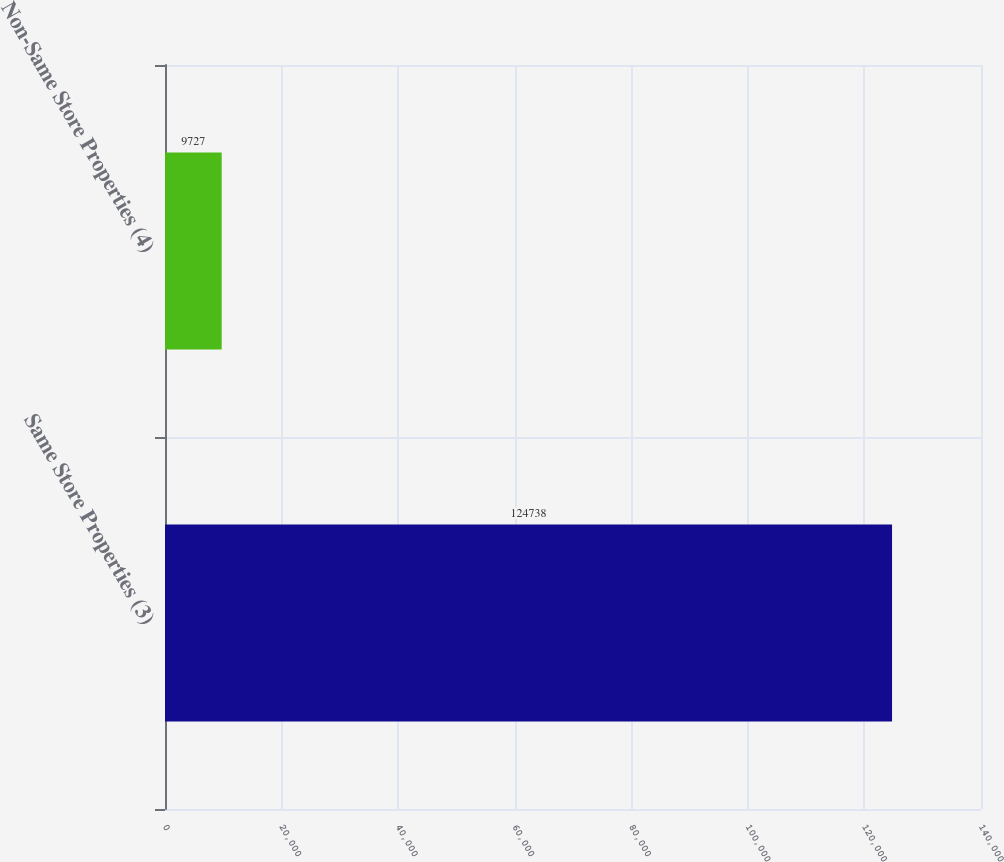Convert chart to OTSL. <chart><loc_0><loc_0><loc_500><loc_500><bar_chart><fcel>Same Store Properties (3)<fcel>Non-Same Store Properties (4)<nl><fcel>124738<fcel>9727<nl></chart> 